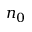<formula> <loc_0><loc_0><loc_500><loc_500>n _ { 0 }</formula> 